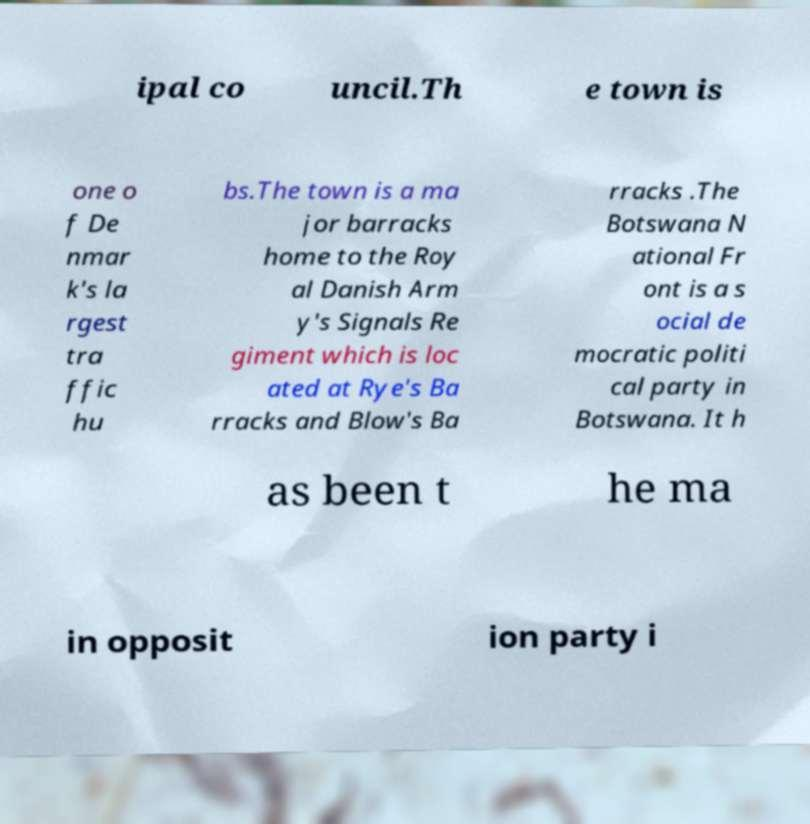Could you assist in decoding the text presented in this image and type it out clearly? ipal co uncil.Th e town is one o f De nmar k's la rgest tra ffic hu bs.The town is a ma jor barracks home to the Roy al Danish Arm y's Signals Re giment which is loc ated at Rye's Ba rracks and Blow's Ba rracks .The Botswana N ational Fr ont is a s ocial de mocratic politi cal party in Botswana. It h as been t he ma in opposit ion party i 